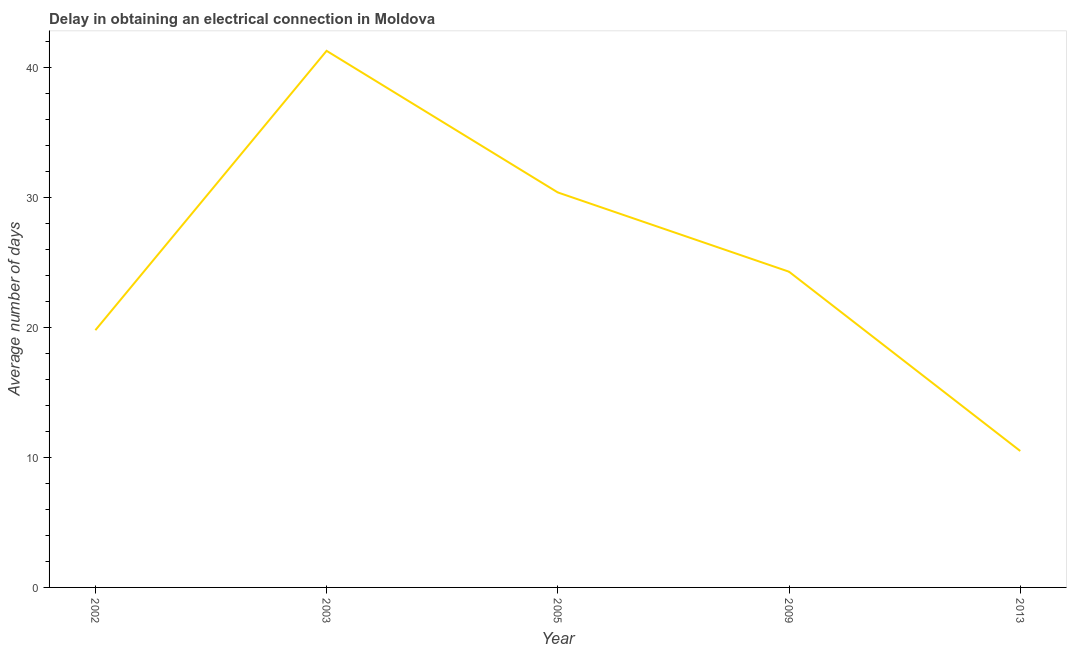What is the dalay in electrical connection in 2005?
Keep it short and to the point. 30.4. Across all years, what is the maximum dalay in electrical connection?
Give a very brief answer. 41.3. In which year was the dalay in electrical connection maximum?
Ensure brevity in your answer.  2003. In which year was the dalay in electrical connection minimum?
Offer a terse response. 2013. What is the sum of the dalay in electrical connection?
Keep it short and to the point. 126.3. What is the difference between the dalay in electrical connection in 2009 and 2013?
Your response must be concise. 13.8. What is the average dalay in electrical connection per year?
Your answer should be compact. 25.26. What is the median dalay in electrical connection?
Your answer should be very brief. 24.3. In how many years, is the dalay in electrical connection greater than 26 days?
Your response must be concise. 2. What is the ratio of the dalay in electrical connection in 2003 to that in 2005?
Offer a terse response. 1.36. What is the difference between the highest and the second highest dalay in electrical connection?
Your response must be concise. 10.9. What is the difference between the highest and the lowest dalay in electrical connection?
Offer a very short reply. 30.8. Does the dalay in electrical connection monotonically increase over the years?
Keep it short and to the point. No. What is the difference between two consecutive major ticks on the Y-axis?
Give a very brief answer. 10. Does the graph contain any zero values?
Provide a short and direct response. No. Does the graph contain grids?
Offer a terse response. No. What is the title of the graph?
Your answer should be compact. Delay in obtaining an electrical connection in Moldova. What is the label or title of the X-axis?
Give a very brief answer. Year. What is the label or title of the Y-axis?
Provide a succinct answer. Average number of days. What is the Average number of days of 2002?
Provide a succinct answer. 19.8. What is the Average number of days of 2003?
Your response must be concise. 41.3. What is the Average number of days of 2005?
Your answer should be very brief. 30.4. What is the Average number of days in 2009?
Your answer should be compact. 24.3. What is the Average number of days in 2013?
Keep it short and to the point. 10.5. What is the difference between the Average number of days in 2002 and 2003?
Provide a short and direct response. -21.5. What is the difference between the Average number of days in 2002 and 2005?
Provide a succinct answer. -10.6. What is the difference between the Average number of days in 2002 and 2013?
Give a very brief answer. 9.3. What is the difference between the Average number of days in 2003 and 2005?
Offer a terse response. 10.9. What is the difference between the Average number of days in 2003 and 2013?
Make the answer very short. 30.8. What is the ratio of the Average number of days in 2002 to that in 2003?
Offer a very short reply. 0.48. What is the ratio of the Average number of days in 2002 to that in 2005?
Provide a succinct answer. 0.65. What is the ratio of the Average number of days in 2002 to that in 2009?
Your answer should be very brief. 0.81. What is the ratio of the Average number of days in 2002 to that in 2013?
Offer a very short reply. 1.89. What is the ratio of the Average number of days in 2003 to that in 2005?
Make the answer very short. 1.36. What is the ratio of the Average number of days in 2003 to that in 2013?
Your answer should be very brief. 3.93. What is the ratio of the Average number of days in 2005 to that in 2009?
Provide a short and direct response. 1.25. What is the ratio of the Average number of days in 2005 to that in 2013?
Your answer should be very brief. 2.9. What is the ratio of the Average number of days in 2009 to that in 2013?
Offer a very short reply. 2.31. 